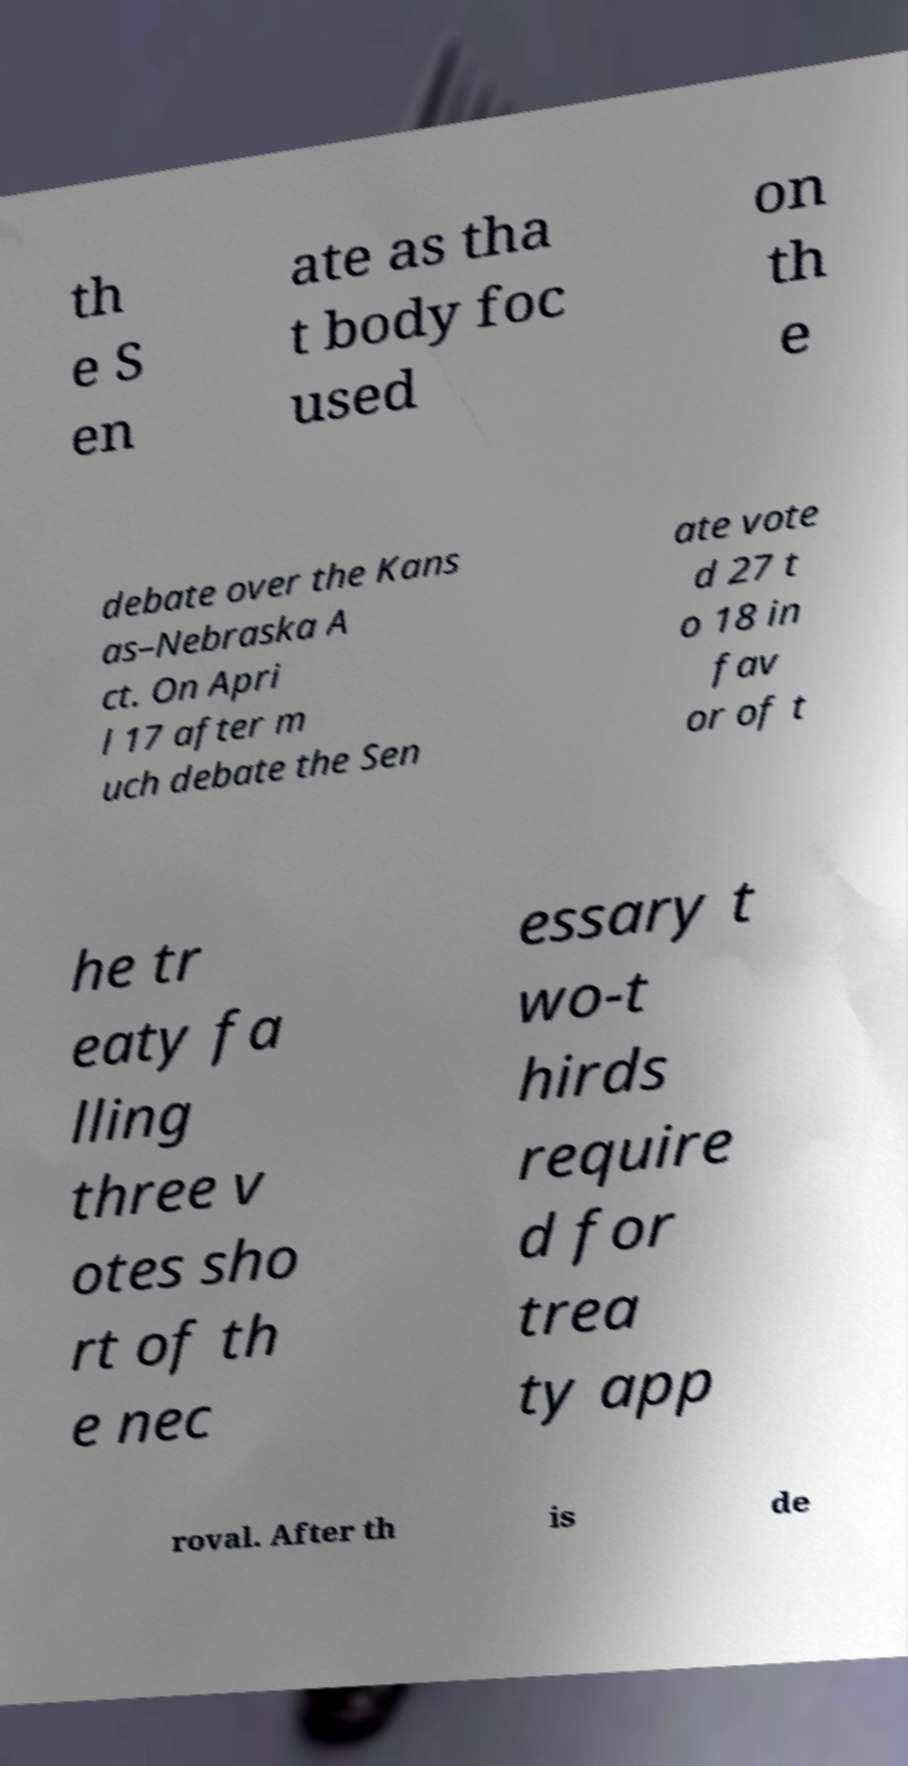Could you extract and type out the text from this image? th e S en ate as tha t body foc used on th e debate over the Kans as–Nebraska A ct. On Apri l 17 after m uch debate the Sen ate vote d 27 t o 18 in fav or of t he tr eaty fa lling three v otes sho rt of th e nec essary t wo-t hirds require d for trea ty app roval. After th is de 